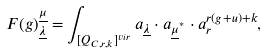Convert formula to latex. <formula><loc_0><loc_0><loc_500><loc_500>F ( g ) _ { \underline { \lambda } } ^ { \underline { \mu } } = \int _ { [ Q _ { C , r , k } ] ^ { v i r } } a _ { \underline { \lambda } } \cdot a _ { \underline { \mu } ^ { ^ { * } } } \cdot a _ { r } ^ { r ( g + u ) + k } ,</formula> 